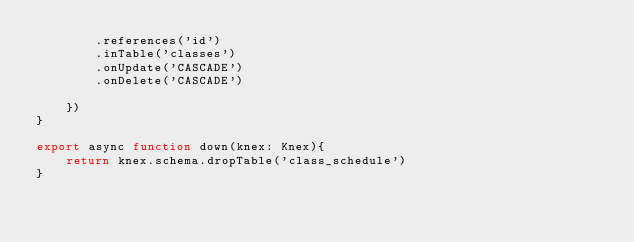Convert code to text. <code><loc_0><loc_0><loc_500><loc_500><_TypeScript_>        .references('id')
        .inTable('classes')
        .onUpdate('CASCADE')
        .onDelete('CASCADE')
        
    })
}

export async function down(knex: Knex){
    return knex.schema.dropTable('class_schedule')
}

</code> 